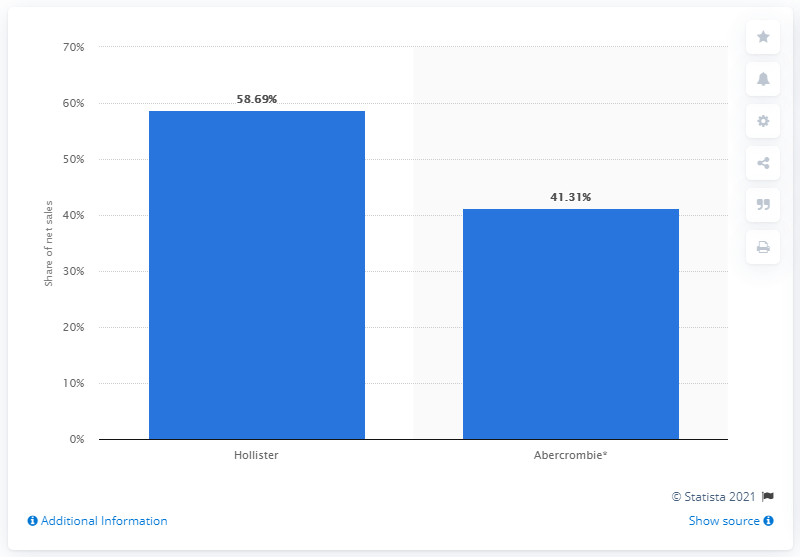Indicate a few pertinent items in this graphic. In 2020, the brand Hollister had a 58.69% share of Abercrombie & Fitch Co.'s total sales. 